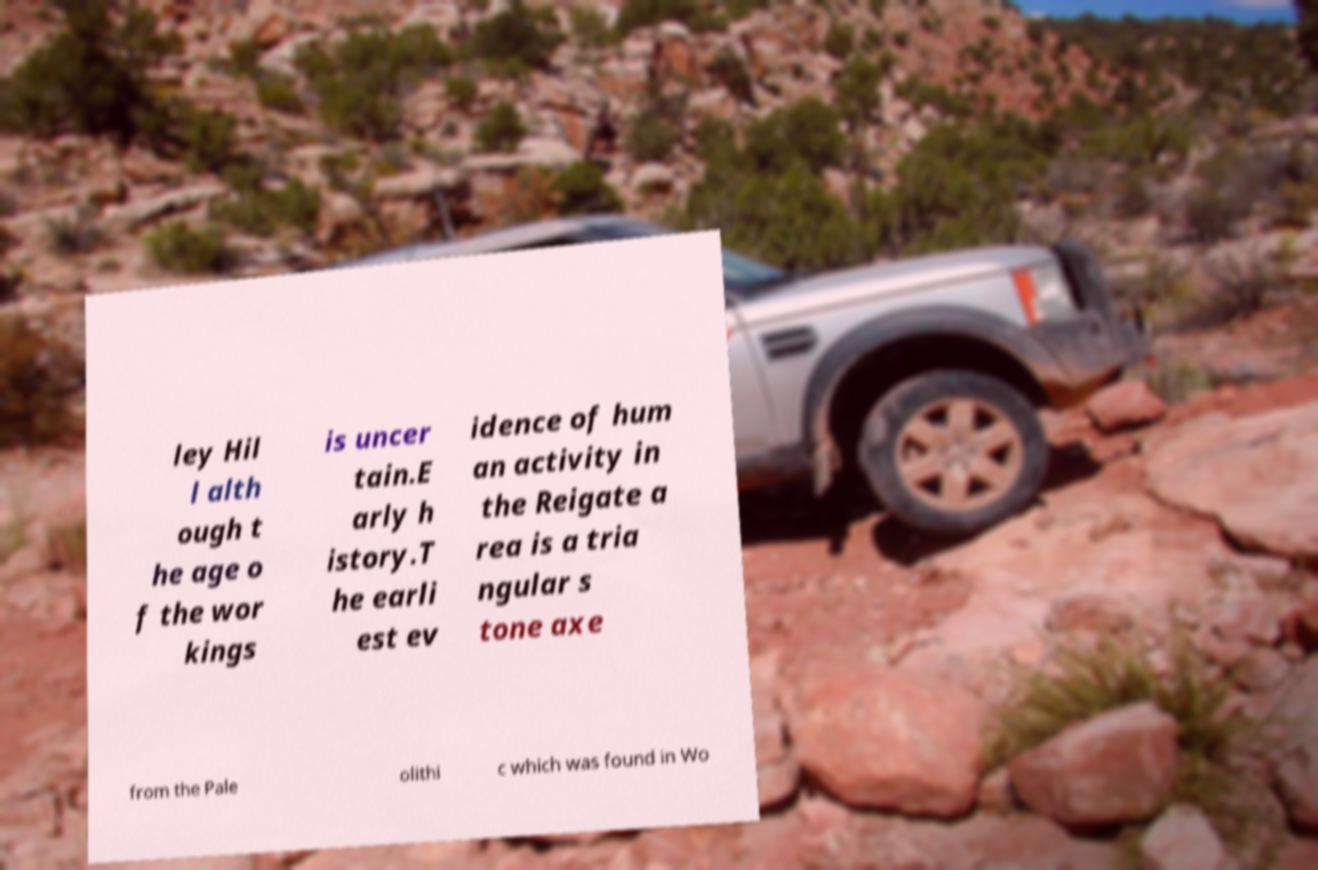Could you assist in decoding the text presented in this image and type it out clearly? ley Hil l alth ough t he age o f the wor kings is uncer tain.E arly h istory.T he earli est ev idence of hum an activity in the Reigate a rea is a tria ngular s tone axe from the Pale olithi c which was found in Wo 